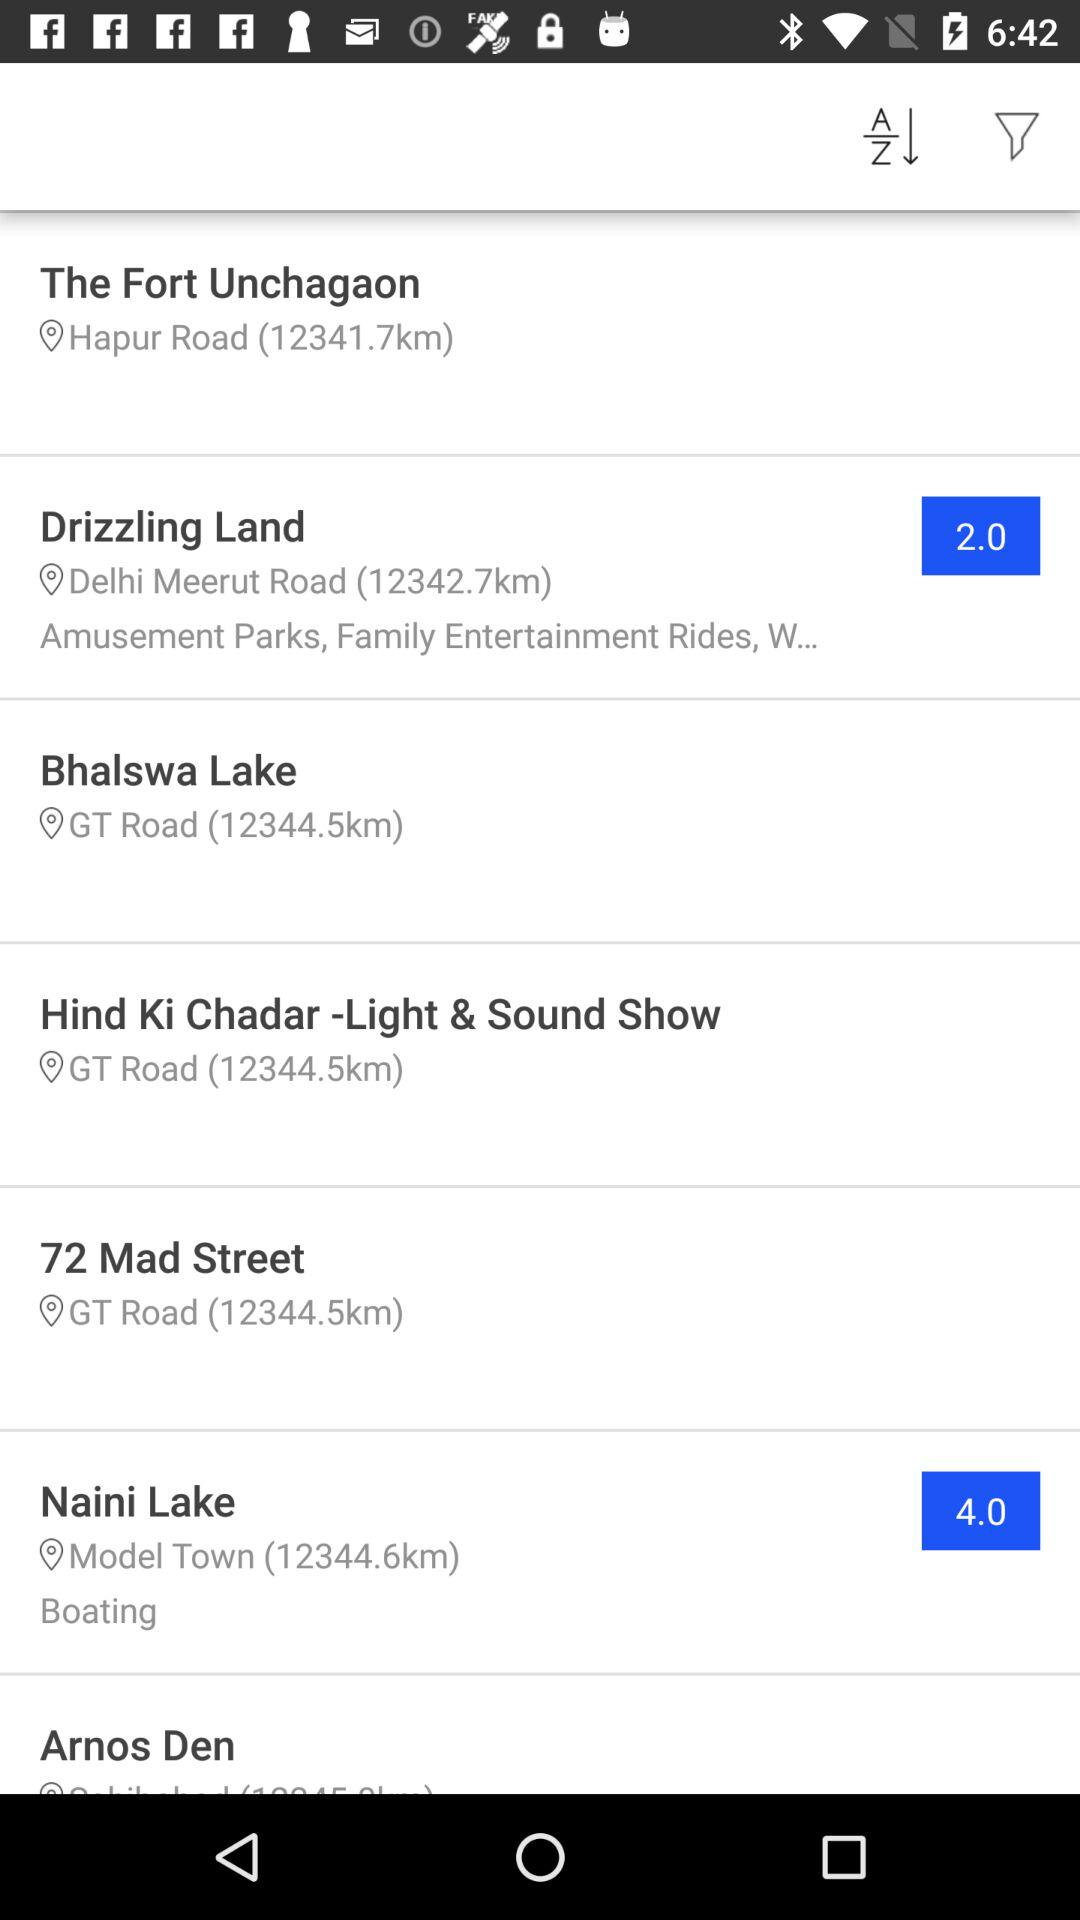Where is "Drizzling Land"? It is on Delhi Meerut Road. 